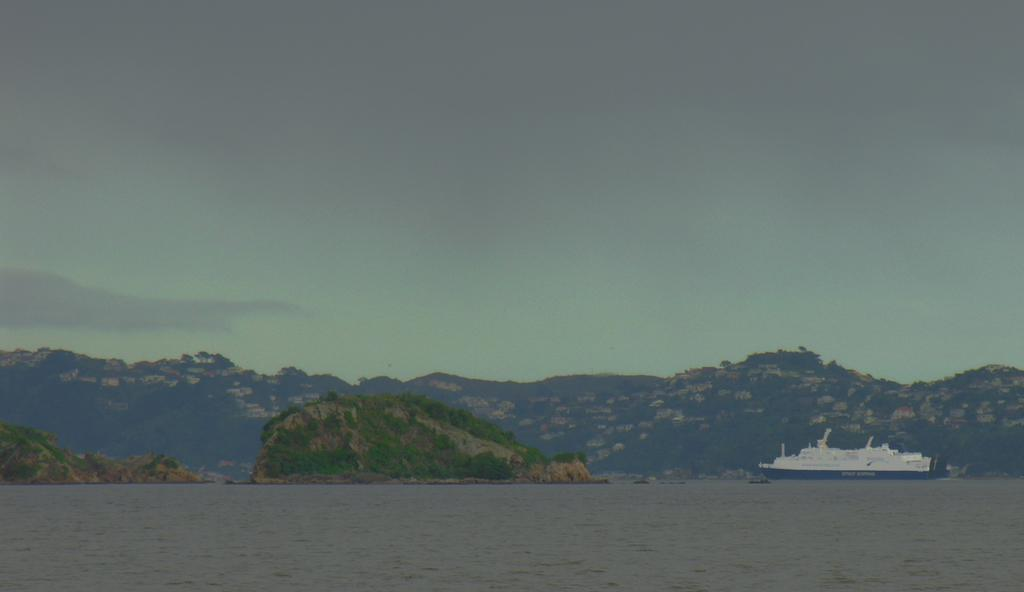What is located in the front of the image? There is water in the front of the image. What is the main subject in the center of the image? There is a boat in the center of the image. What can be seen in the background of the image? There are mountains in the background of the image. How would you describe the sky in the image? The sky is cloudy. Can you see a fan in the image? There is no fan present in the image. What type of lipstick is the person wearing in the image? There is no person wearing lipstick in the image, as it features a boat on water with mountains in the background. 